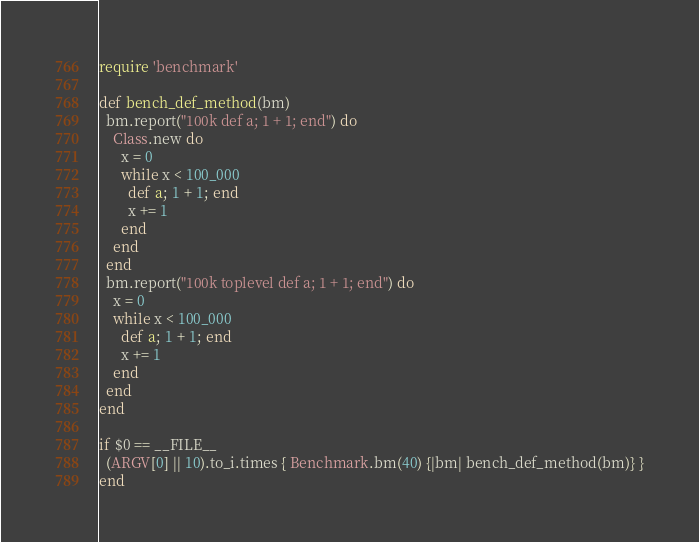Convert code to text. <code><loc_0><loc_0><loc_500><loc_500><_Ruby_>require 'benchmark'

def bench_def_method(bm)
  bm.report("100k def a; 1 + 1; end") do
    Class.new do
      x = 0
      while x < 100_000
        def a; 1 + 1; end
        x += 1
      end
    end
  end
  bm.report("100k toplevel def a; 1 + 1; end") do
    x = 0
    while x < 100_000
      def a; 1 + 1; end
      x += 1
    end
  end
end

if $0 == __FILE__
  (ARGV[0] || 10).to_i.times { Benchmark.bm(40) {|bm| bench_def_method(bm)} }
end
</code> 